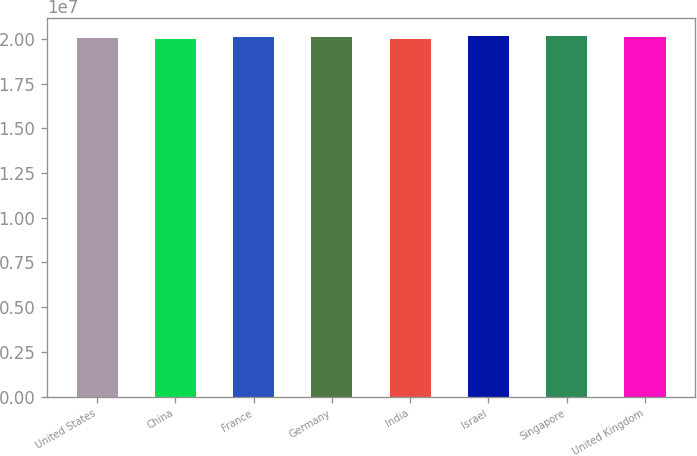Convert chart. <chart><loc_0><loc_0><loc_500><loc_500><bar_chart><fcel>United States<fcel>China<fcel>France<fcel>Germany<fcel>India<fcel>Israel<fcel>Singapore<fcel>United Kingdom<nl><fcel>2.0082e+07<fcel>2.0022e+07<fcel>2.0127e+07<fcel>2.0097e+07<fcel>1.9972e+07<fcel>2.0157e+07<fcel>2.0142e+07<fcel>2.0112e+07<nl></chart> 